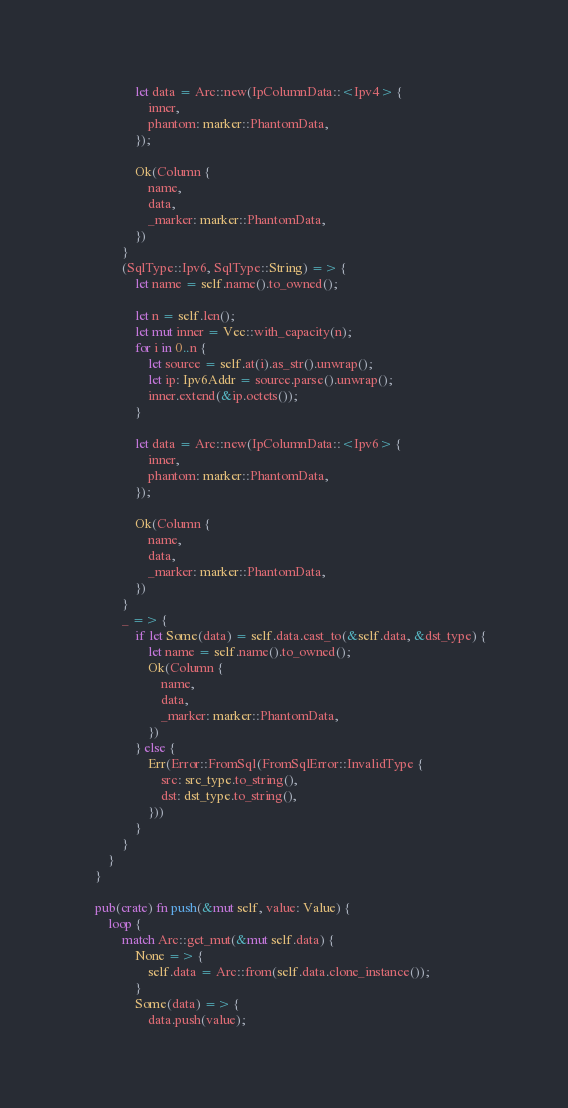<code> <loc_0><loc_0><loc_500><loc_500><_Rust_>
                let data = Arc::new(IpColumnData::<Ipv4> {
                    inner,
                    phantom: marker::PhantomData,
                });

                Ok(Column {
                    name,
                    data,
                    _marker: marker::PhantomData,
                })
            }
            (SqlType::Ipv6, SqlType::String) => {
                let name = self.name().to_owned();

                let n = self.len();
                let mut inner = Vec::with_capacity(n);
                for i in 0..n {
                    let source = self.at(i).as_str().unwrap();
                    let ip: Ipv6Addr = source.parse().unwrap();
                    inner.extend(&ip.octets());
                }

                let data = Arc::new(IpColumnData::<Ipv6> {
                    inner,
                    phantom: marker::PhantomData,
                });

                Ok(Column {
                    name,
                    data,
                    _marker: marker::PhantomData,
                })
            }
            _ => {
                if let Some(data) = self.data.cast_to(&self.data, &dst_type) {
                    let name = self.name().to_owned();
                    Ok(Column {
                        name,
                        data,
                        _marker: marker::PhantomData,
                    })
                } else {
                    Err(Error::FromSql(FromSqlError::InvalidType {
                        src: src_type.to_string(),
                        dst: dst_type.to_string(),
                    }))
                }
            }
        }
    }

    pub(crate) fn push(&mut self, value: Value) {
        loop {
            match Arc::get_mut(&mut self.data) {
                None => {
                    self.data = Arc::from(self.data.clone_instance());
                }
                Some(data) => {
                    data.push(value);</code> 